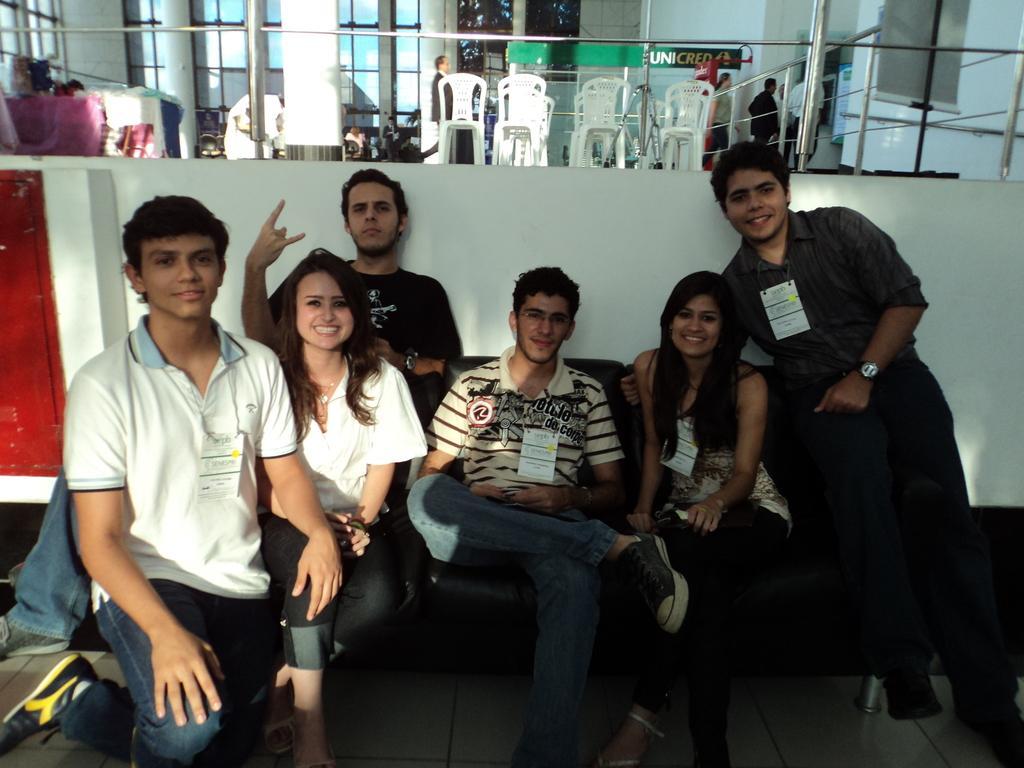Please provide a concise description of this image. On the left side a boy is there, he wore white color t-shirt and jeans trouser. beside him a beautiful girl is sitting, she is smiling and beside her 4 persons are there. At the top there are chairs in this image. 